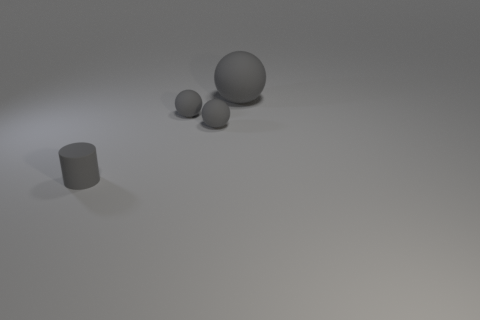Subtract all gray spheres. How many were subtracted if there are1gray spheres left? 2 Subtract all small balls. How many balls are left? 1 Add 4 gray spheres. How many objects exist? 8 Subtract all cylinders. How many objects are left? 3 Add 1 gray spheres. How many gray spheres exist? 4 Subtract 0 yellow spheres. How many objects are left? 4 Subtract all big green objects. Subtract all gray matte objects. How many objects are left? 0 Add 4 cylinders. How many cylinders are left? 5 